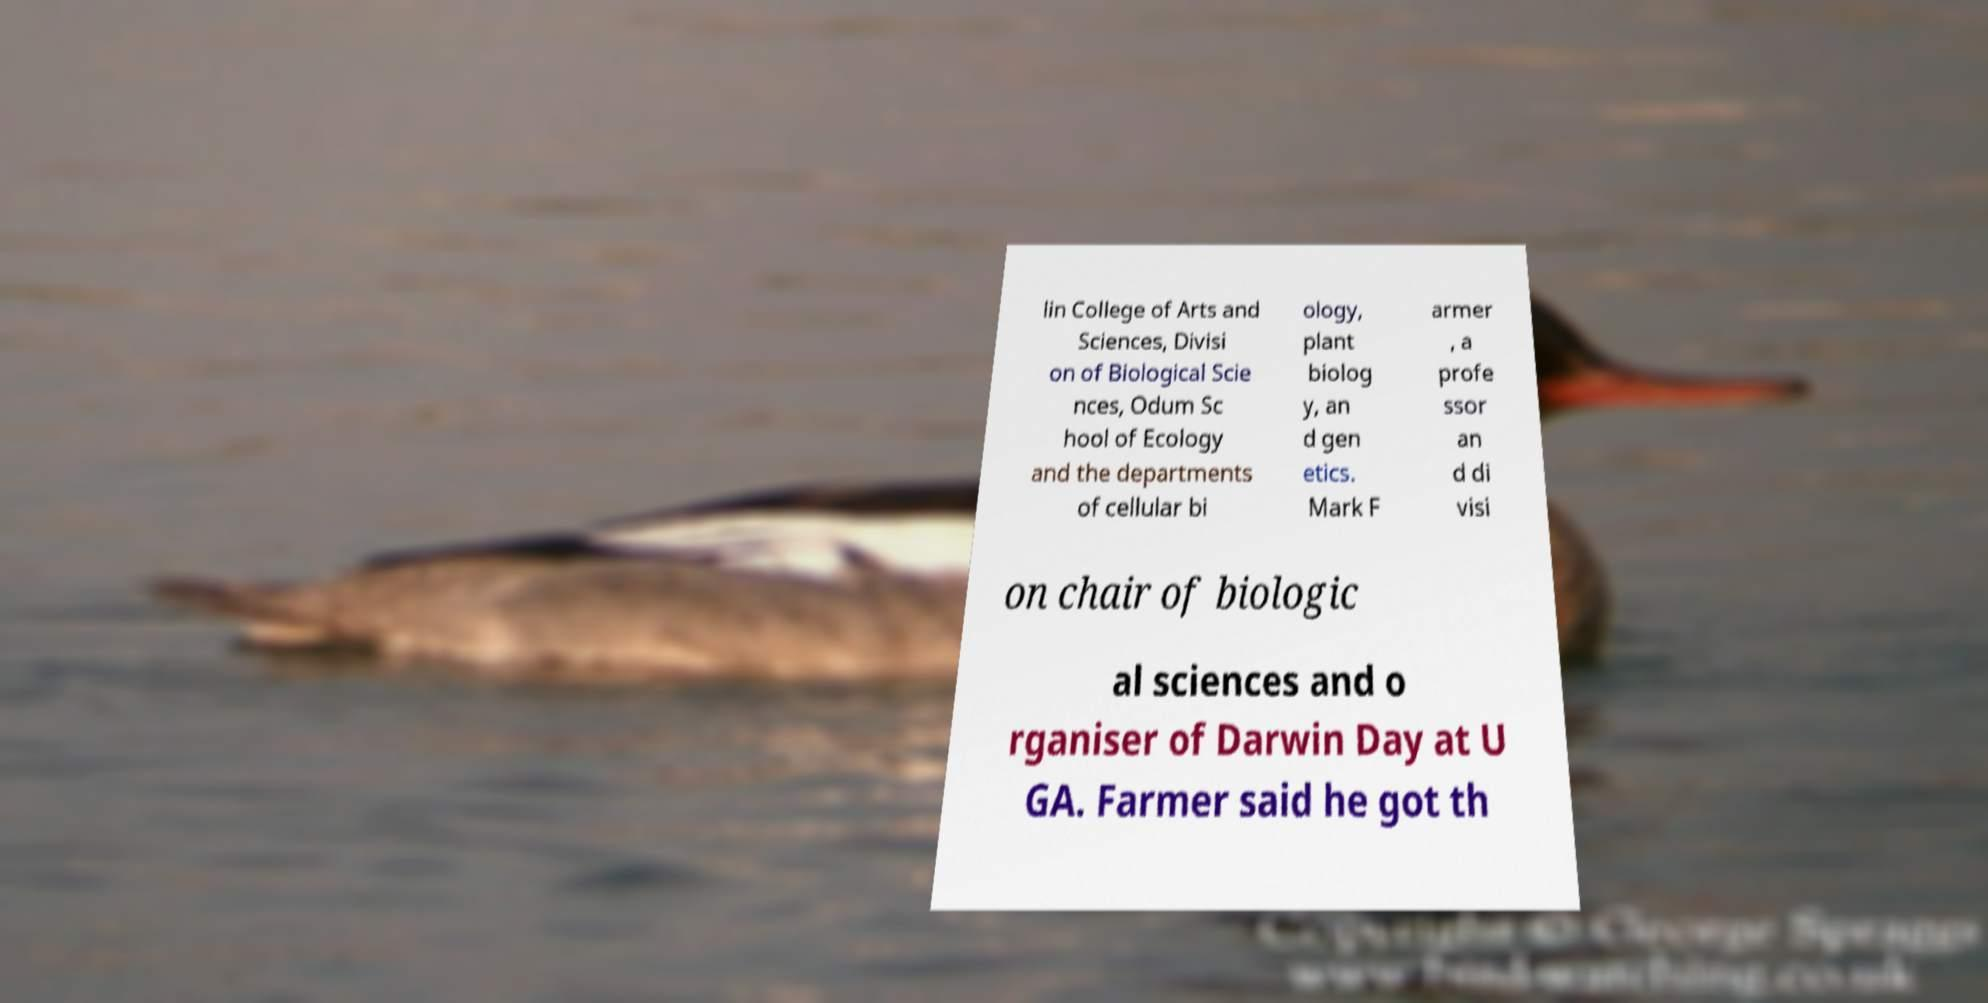Could you extract and type out the text from this image? lin College of Arts and Sciences, Divisi on of Biological Scie nces, Odum Sc hool of Ecology and the departments of cellular bi ology, plant biolog y, an d gen etics. Mark F armer , a profe ssor an d di visi on chair of biologic al sciences and o rganiser of Darwin Day at U GA. Farmer said he got th 